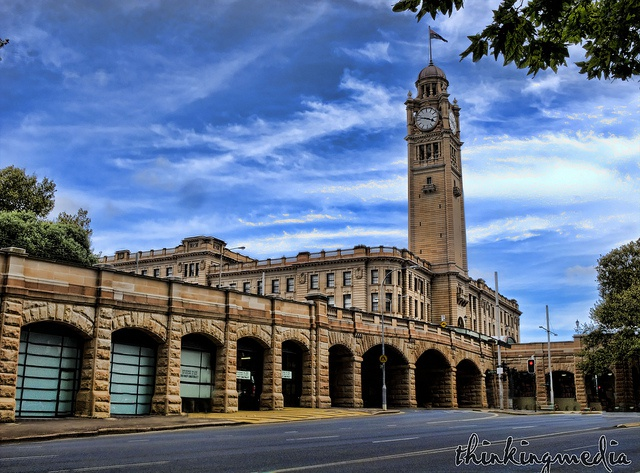Describe the objects in this image and their specific colors. I can see clock in gray and black tones, clock in gray, darkgray, and black tones, traffic light in gray, black, darkgray, and maroon tones, traffic light in gray, black, and maroon tones, and traffic light in black and gray tones in this image. 